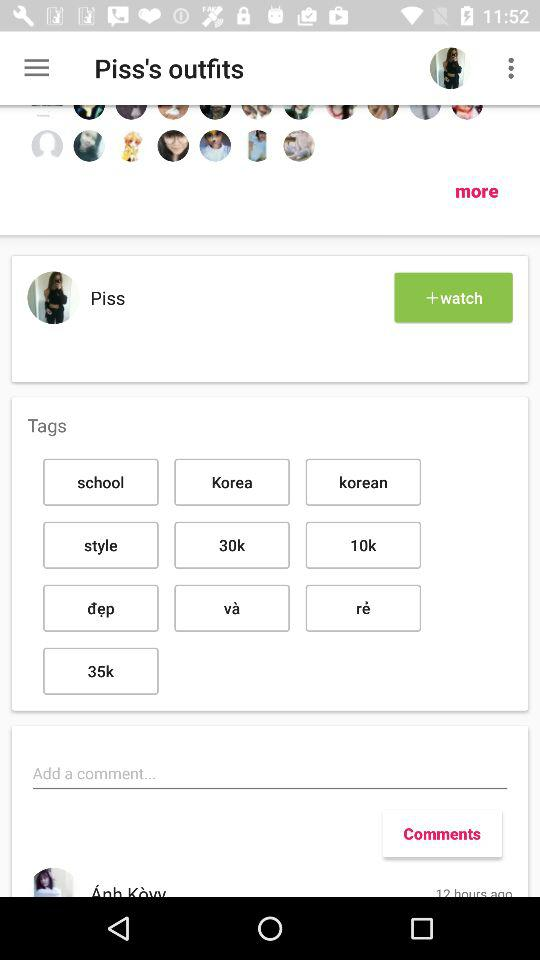How many likes are on the post?
When the provided information is insufficient, respond with <no answer>. <no answer> 